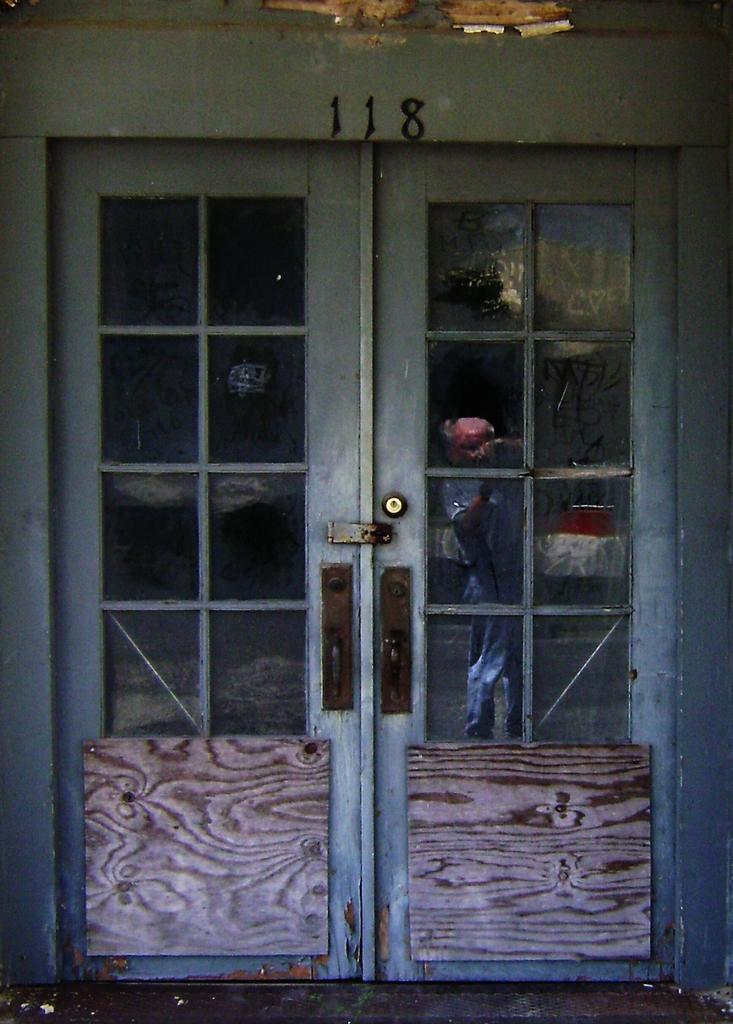What is the main object in the middle of the image? There is a door in the middle of the image. What is unique about the door? The door has blocks of glasses. What is supporting the door at the bottom? There are two wooden planks at the bottom of the doors. How many cakes are placed on top of the door in the image? There are no cakes present on top of the door in the image. 